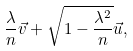Convert formula to latex. <formula><loc_0><loc_0><loc_500><loc_500>\frac { \lambda } { n } \vec { v } + \sqrt { 1 - \frac { \lambda ^ { 2 } } { n } } \vec { u } ,</formula> 